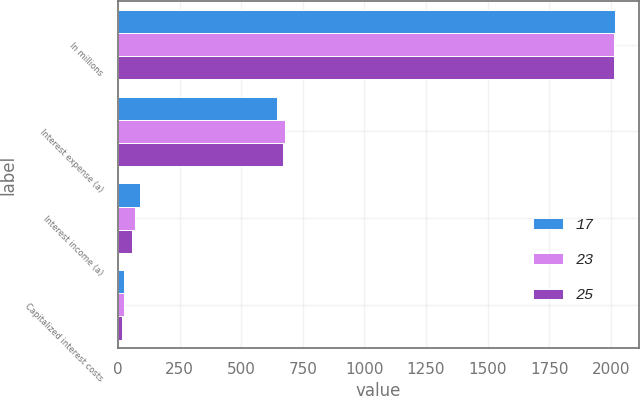Convert chart to OTSL. <chart><loc_0><loc_0><loc_500><loc_500><stacked_bar_chart><ecel><fcel>In millions<fcel>Interest expense (a)<fcel>Interest income (a)<fcel>Capitalized interest costs<nl><fcel>17<fcel>2015<fcel>644<fcel>89<fcel>25<nl><fcel>23<fcel>2014<fcel>677<fcel>70<fcel>23<nl><fcel>25<fcel>2013<fcel>669<fcel>57<fcel>17<nl></chart> 